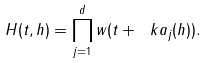<formula> <loc_0><loc_0><loc_500><loc_500>H ( t , h ) = \prod _ { j = 1 } ^ { d } w ( t + \ k a _ { j } ( h ) ) .</formula> 